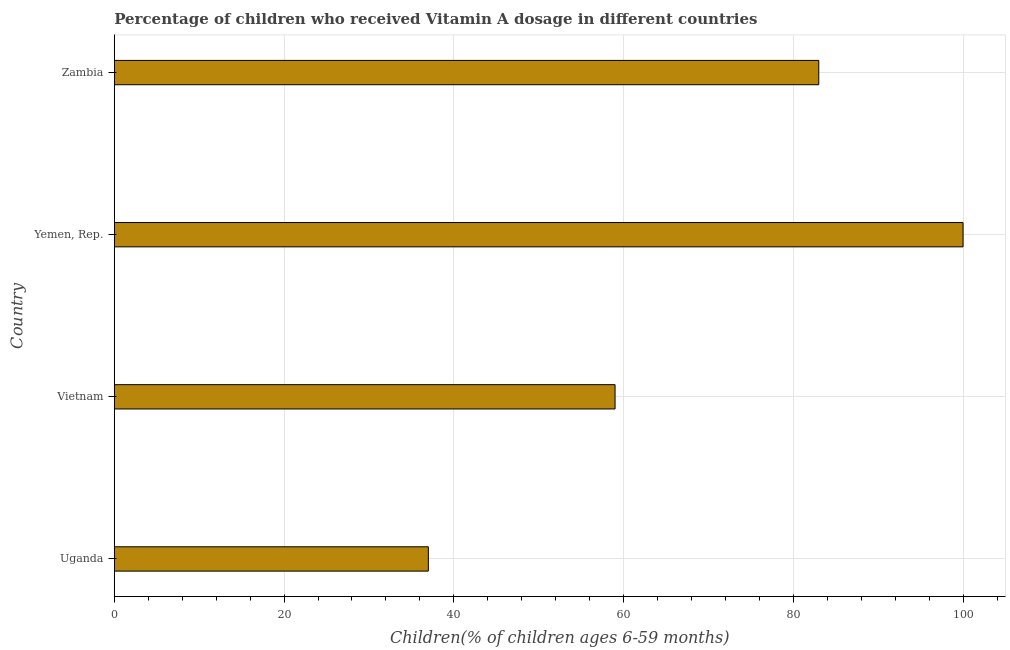What is the title of the graph?
Your response must be concise. Percentage of children who received Vitamin A dosage in different countries. What is the label or title of the X-axis?
Your response must be concise. Children(% of children ages 6-59 months). What is the label or title of the Y-axis?
Give a very brief answer. Country. Across all countries, what is the maximum vitamin a supplementation coverage rate?
Your answer should be compact. 100. Across all countries, what is the minimum vitamin a supplementation coverage rate?
Make the answer very short. 37. In which country was the vitamin a supplementation coverage rate maximum?
Make the answer very short. Yemen, Rep. In which country was the vitamin a supplementation coverage rate minimum?
Your response must be concise. Uganda. What is the sum of the vitamin a supplementation coverage rate?
Ensure brevity in your answer.  279. What is the difference between the vitamin a supplementation coverage rate in Yemen, Rep. and Zambia?
Ensure brevity in your answer.  17. What is the average vitamin a supplementation coverage rate per country?
Give a very brief answer. 69.75. In how many countries, is the vitamin a supplementation coverage rate greater than 72 %?
Your answer should be compact. 2. What is the ratio of the vitamin a supplementation coverage rate in Uganda to that in Yemen, Rep.?
Give a very brief answer. 0.37. Is the vitamin a supplementation coverage rate in Vietnam less than that in Yemen, Rep.?
Provide a succinct answer. Yes. Is the sum of the vitamin a supplementation coverage rate in Yemen, Rep. and Zambia greater than the maximum vitamin a supplementation coverage rate across all countries?
Keep it short and to the point. Yes. What is the difference between the highest and the lowest vitamin a supplementation coverage rate?
Provide a short and direct response. 63. In how many countries, is the vitamin a supplementation coverage rate greater than the average vitamin a supplementation coverage rate taken over all countries?
Make the answer very short. 2. How many bars are there?
Keep it short and to the point. 4. How many countries are there in the graph?
Your response must be concise. 4. What is the difference between two consecutive major ticks on the X-axis?
Make the answer very short. 20. What is the Children(% of children ages 6-59 months) in Vietnam?
Your answer should be compact. 59. What is the Children(% of children ages 6-59 months) of Yemen, Rep.?
Your response must be concise. 100. What is the difference between the Children(% of children ages 6-59 months) in Uganda and Yemen, Rep.?
Offer a terse response. -63. What is the difference between the Children(% of children ages 6-59 months) in Uganda and Zambia?
Offer a terse response. -46. What is the difference between the Children(% of children ages 6-59 months) in Vietnam and Yemen, Rep.?
Give a very brief answer. -41. What is the difference between the Children(% of children ages 6-59 months) in Yemen, Rep. and Zambia?
Give a very brief answer. 17. What is the ratio of the Children(% of children ages 6-59 months) in Uganda to that in Vietnam?
Keep it short and to the point. 0.63. What is the ratio of the Children(% of children ages 6-59 months) in Uganda to that in Yemen, Rep.?
Provide a succinct answer. 0.37. What is the ratio of the Children(% of children ages 6-59 months) in Uganda to that in Zambia?
Provide a short and direct response. 0.45. What is the ratio of the Children(% of children ages 6-59 months) in Vietnam to that in Yemen, Rep.?
Your response must be concise. 0.59. What is the ratio of the Children(% of children ages 6-59 months) in Vietnam to that in Zambia?
Your response must be concise. 0.71. What is the ratio of the Children(% of children ages 6-59 months) in Yemen, Rep. to that in Zambia?
Your response must be concise. 1.21. 